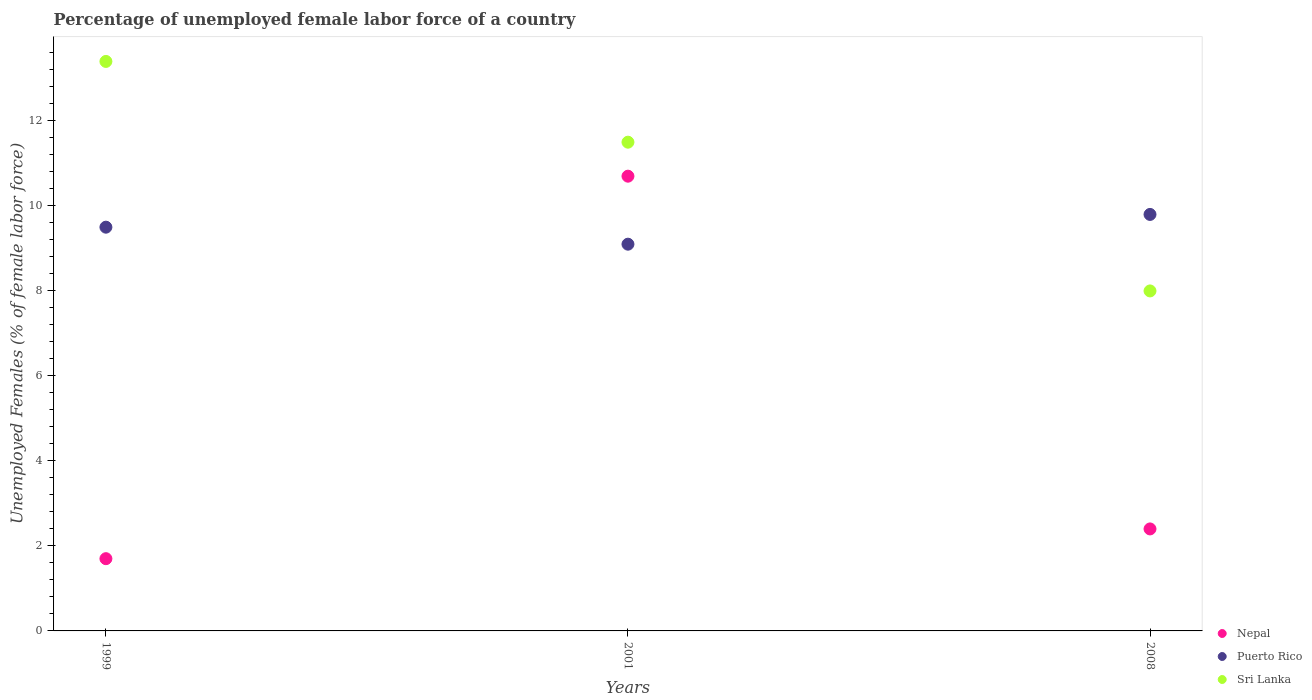What is the percentage of unemployed female labor force in Sri Lanka in 2008?
Ensure brevity in your answer.  8. Across all years, what is the maximum percentage of unemployed female labor force in Sri Lanka?
Your answer should be compact. 13.4. What is the total percentage of unemployed female labor force in Puerto Rico in the graph?
Your answer should be compact. 28.4. What is the difference between the percentage of unemployed female labor force in Sri Lanka in 1999 and that in 2008?
Your response must be concise. 5.4. What is the difference between the percentage of unemployed female labor force in Nepal in 1999 and the percentage of unemployed female labor force in Puerto Rico in 2008?
Give a very brief answer. -8.1. What is the average percentage of unemployed female labor force in Nepal per year?
Offer a very short reply. 4.93. In the year 1999, what is the difference between the percentage of unemployed female labor force in Sri Lanka and percentage of unemployed female labor force in Puerto Rico?
Your response must be concise. 3.9. What is the ratio of the percentage of unemployed female labor force in Sri Lanka in 1999 to that in 2008?
Provide a short and direct response. 1.67. Is the percentage of unemployed female labor force in Sri Lanka in 2001 less than that in 2008?
Your response must be concise. No. Is the difference between the percentage of unemployed female labor force in Sri Lanka in 2001 and 2008 greater than the difference between the percentage of unemployed female labor force in Puerto Rico in 2001 and 2008?
Offer a very short reply. Yes. What is the difference between the highest and the second highest percentage of unemployed female labor force in Sri Lanka?
Your answer should be very brief. 1.9. What is the difference between the highest and the lowest percentage of unemployed female labor force in Nepal?
Provide a succinct answer. 9. In how many years, is the percentage of unemployed female labor force in Puerto Rico greater than the average percentage of unemployed female labor force in Puerto Rico taken over all years?
Give a very brief answer. 2. Is the sum of the percentage of unemployed female labor force in Sri Lanka in 1999 and 2001 greater than the maximum percentage of unemployed female labor force in Puerto Rico across all years?
Give a very brief answer. Yes. Is the percentage of unemployed female labor force in Puerto Rico strictly less than the percentage of unemployed female labor force in Nepal over the years?
Your answer should be compact. No. How many dotlines are there?
Give a very brief answer. 3. How many years are there in the graph?
Make the answer very short. 3. What is the difference between two consecutive major ticks on the Y-axis?
Ensure brevity in your answer.  2. Are the values on the major ticks of Y-axis written in scientific E-notation?
Offer a terse response. No. Does the graph contain any zero values?
Give a very brief answer. No. Does the graph contain grids?
Your response must be concise. No. Where does the legend appear in the graph?
Your answer should be very brief. Bottom right. How many legend labels are there?
Your response must be concise. 3. How are the legend labels stacked?
Keep it short and to the point. Vertical. What is the title of the graph?
Provide a succinct answer. Percentage of unemployed female labor force of a country. What is the label or title of the Y-axis?
Offer a terse response. Unemployed Females (% of female labor force). What is the Unemployed Females (% of female labor force) of Nepal in 1999?
Ensure brevity in your answer.  1.7. What is the Unemployed Females (% of female labor force) in Puerto Rico in 1999?
Ensure brevity in your answer.  9.5. What is the Unemployed Females (% of female labor force) of Sri Lanka in 1999?
Give a very brief answer. 13.4. What is the Unemployed Females (% of female labor force) of Nepal in 2001?
Provide a short and direct response. 10.7. What is the Unemployed Females (% of female labor force) in Puerto Rico in 2001?
Provide a short and direct response. 9.1. What is the Unemployed Females (% of female labor force) of Nepal in 2008?
Offer a very short reply. 2.4. What is the Unemployed Females (% of female labor force) in Puerto Rico in 2008?
Offer a very short reply. 9.8. Across all years, what is the maximum Unemployed Females (% of female labor force) of Nepal?
Offer a terse response. 10.7. Across all years, what is the maximum Unemployed Females (% of female labor force) of Puerto Rico?
Your answer should be compact. 9.8. Across all years, what is the maximum Unemployed Females (% of female labor force) of Sri Lanka?
Make the answer very short. 13.4. Across all years, what is the minimum Unemployed Females (% of female labor force) in Nepal?
Provide a succinct answer. 1.7. Across all years, what is the minimum Unemployed Females (% of female labor force) of Puerto Rico?
Your response must be concise. 9.1. Across all years, what is the minimum Unemployed Females (% of female labor force) in Sri Lanka?
Your response must be concise. 8. What is the total Unemployed Females (% of female labor force) in Puerto Rico in the graph?
Provide a short and direct response. 28.4. What is the total Unemployed Females (% of female labor force) of Sri Lanka in the graph?
Keep it short and to the point. 32.9. What is the difference between the Unemployed Females (% of female labor force) in Sri Lanka in 1999 and that in 2008?
Keep it short and to the point. 5.4. What is the difference between the Unemployed Females (% of female labor force) in Nepal in 2001 and that in 2008?
Give a very brief answer. 8.3. What is the difference between the Unemployed Females (% of female labor force) in Puerto Rico in 2001 and that in 2008?
Provide a succinct answer. -0.7. What is the difference between the Unemployed Females (% of female labor force) in Sri Lanka in 2001 and that in 2008?
Your answer should be very brief. 3.5. What is the difference between the Unemployed Females (% of female labor force) of Nepal in 1999 and the Unemployed Females (% of female labor force) of Puerto Rico in 2001?
Your answer should be very brief. -7.4. What is the difference between the Unemployed Females (% of female labor force) of Nepal in 1999 and the Unemployed Females (% of female labor force) of Sri Lanka in 2001?
Offer a very short reply. -9.8. What is the difference between the Unemployed Females (% of female labor force) in Puerto Rico in 1999 and the Unemployed Females (% of female labor force) in Sri Lanka in 2001?
Offer a very short reply. -2. What is the difference between the Unemployed Females (% of female labor force) in Nepal in 1999 and the Unemployed Females (% of female labor force) in Sri Lanka in 2008?
Ensure brevity in your answer.  -6.3. What is the difference between the Unemployed Females (% of female labor force) of Puerto Rico in 1999 and the Unemployed Females (% of female labor force) of Sri Lanka in 2008?
Provide a short and direct response. 1.5. What is the difference between the Unemployed Females (% of female labor force) in Nepal in 2001 and the Unemployed Females (% of female labor force) in Sri Lanka in 2008?
Keep it short and to the point. 2.7. What is the difference between the Unemployed Females (% of female labor force) in Puerto Rico in 2001 and the Unemployed Females (% of female labor force) in Sri Lanka in 2008?
Ensure brevity in your answer.  1.1. What is the average Unemployed Females (% of female labor force) of Nepal per year?
Provide a succinct answer. 4.93. What is the average Unemployed Females (% of female labor force) of Puerto Rico per year?
Your response must be concise. 9.47. What is the average Unemployed Females (% of female labor force) of Sri Lanka per year?
Ensure brevity in your answer.  10.97. In the year 1999, what is the difference between the Unemployed Females (% of female labor force) in Nepal and Unemployed Females (% of female labor force) in Sri Lanka?
Provide a succinct answer. -11.7. In the year 2008, what is the difference between the Unemployed Females (% of female labor force) of Nepal and Unemployed Females (% of female labor force) of Puerto Rico?
Offer a very short reply. -7.4. In the year 2008, what is the difference between the Unemployed Females (% of female labor force) of Nepal and Unemployed Females (% of female labor force) of Sri Lanka?
Offer a very short reply. -5.6. In the year 2008, what is the difference between the Unemployed Females (% of female labor force) of Puerto Rico and Unemployed Females (% of female labor force) of Sri Lanka?
Keep it short and to the point. 1.8. What is the ratio of the Unemployed Females (% of female labor force) in Nepal in 1999 to that in 2001?
Provide a short and direct response. 0.16. What is the ratio of the Unemployed Females (% of female labor force) in Puerto Rico in 1999 to that in 2001?
Your answer should be compact. 1.04. What is the ratio of the Unemployed Females (% of female labor force) in Sri Lanka in 1999 to that in 2001?
Provide a short and direct response. 1.17. What is the ratio of the Unemployed Females (% of female labor force) in Nepal in 1999 to that in 2008?
Offer a terse response. 0.71. What is the ratio of the Unemployed Females (% of female labor force) of Puerto Rico in 1999 to that in 2008?
Offer a very short reply. 0.97. What is the ratio of the Unemployed Females (% of female labor force) in Sri Lanka in 1999 to that in 2008?
Ensure brevity in your answer.  1.68. What is the ratio of the Unemployed Females (% of female labor force) in Nepal in 2001 to that in 2008?
Your answer should be very brief. 4.46. What is the ratio of the Unemployed Females (% of female labor force) in Sri Lanka in 2001 to that in 2008?
Your response must be concise. 1.44. What is the difference between the highest and the second highest Unemployed Females (% of female labor force) in Puerto Rico?
Make the answer very short. 0.3. What is the difference between the highest and the second highest Unemployed Females (% of female labor force) of Sri Lanka?
Ensure brevity in your answer.  1.9. What is the difference between the highest and the lowest Unemployed Females (% of female labor force) in Sri Lanka?
Provide a short and direct response. 5.4. 